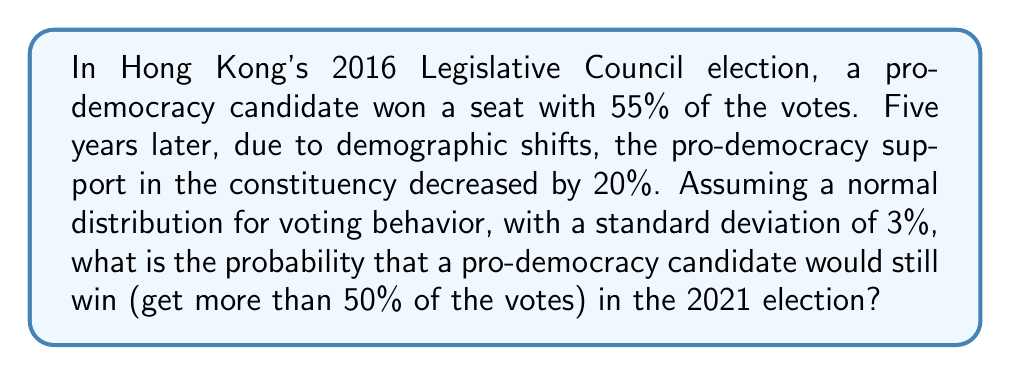Could you help me with this problem? Let's approach this step-by-step:

1) In 2016, the pro-democracy candidate won with 55% of the votes.

2) By 2021, support decreased by 20% of 55%:
   $55\% - (20\% \times 55\%) = 55\% - 11\% = 44\%$

3) We need to find the probability of getting more than 50% of votes, given a mean of 44% and a standard deviation of 3%.

4) To use the standard normal distribution, we need to calculate the z-score:

   $z = \frac{x - \mu}{\sigma} = \frac{50\% - 44\%}{3\%} = \frac{6\%}{3\%} = 2$

5) We want the probability of $X > 50\%$, which is equivalent to $Z > 2$.

6) Using a standard normal distribution table or calculator, we find:
   $P(Z > 2) = 1 - P(Z < 2) = 1 - 0.9772 = 0.0228$

7) Convert to a percentage: $0.0228 \times 100\% = 2.28\%$
Answer: 2.28% 